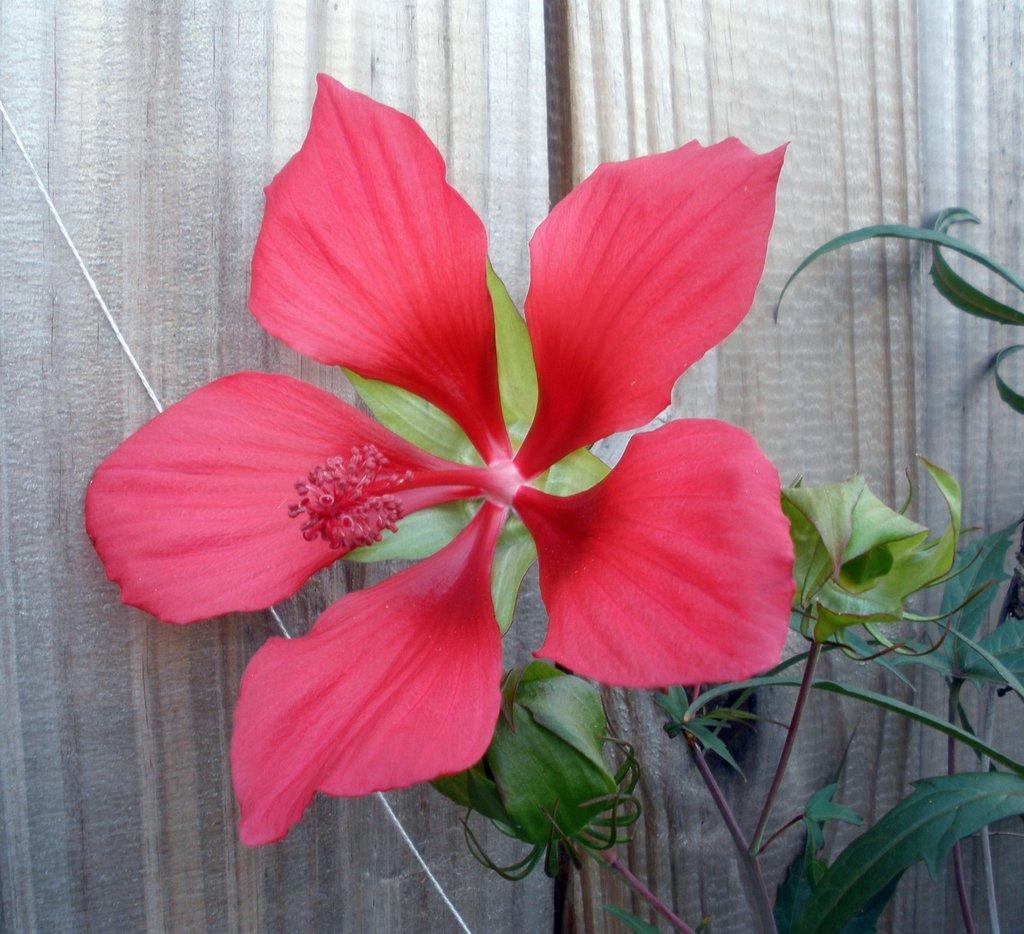What type of flower is in the image? There is a hibiscus flower in the image. Where is the hibiscus flower located? The hibiscus flower is on a plant. What can be seen in the background of the image? There are curtains in the background of the image. How does the army affect the hibiscus flower in the image? There is no army present in the image, so it cannot affect the hibiscus flower. 